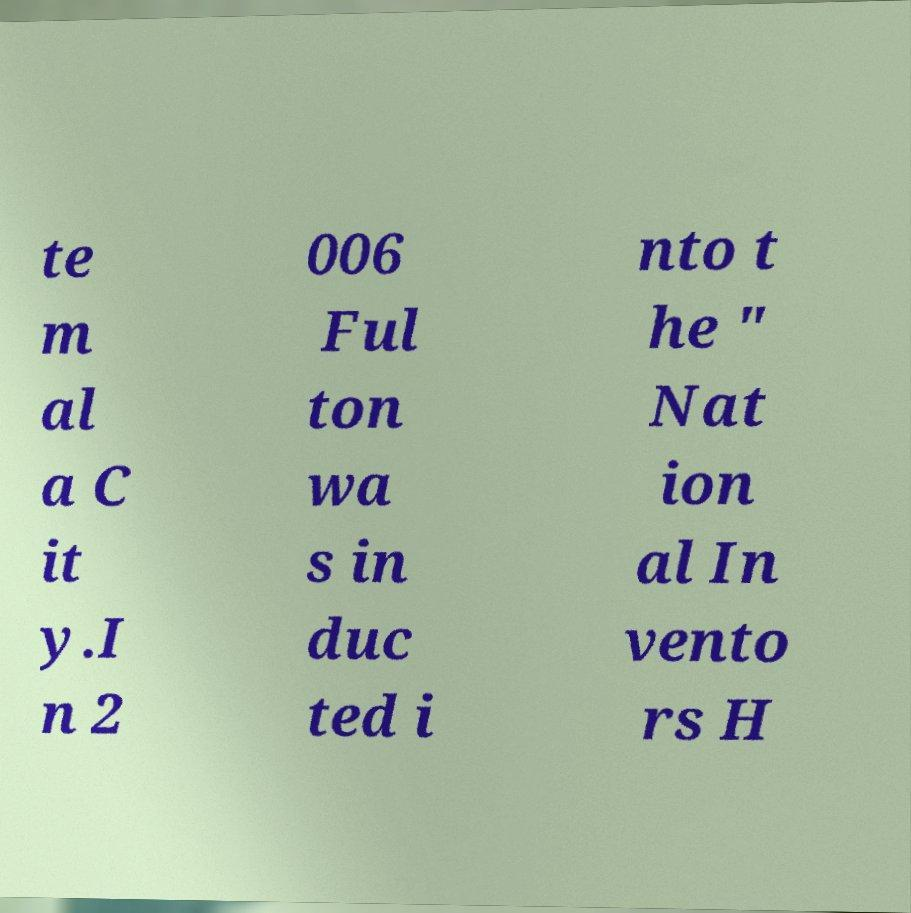Can you read and provide the text displayed in the image?This photo seems to have some interesting text. Can you extract and type it out for me? te m al a C it y.I n 2 006 Ful ton wa s in duc ted i nto t he " Nat ion al In vento rs H 